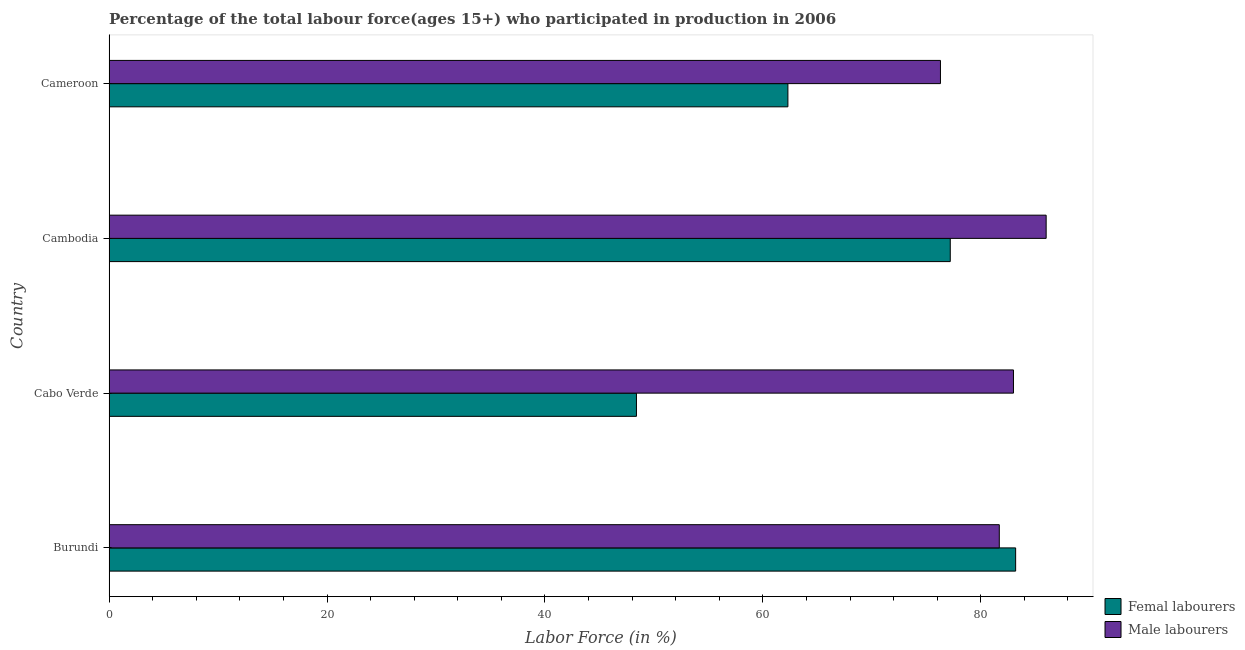How many different coloured bars are there?
Keep it short and to the point. 2. How many groups of bars are there?
Give a very brief answer. 4. Are the number of bars on each tick of the Y-axis equal?
Your answer should be compact. Yes. How many bars are there on the 2nd tick from the top?
Offer a terse response. 2. How many bars are there on the 2nd tick from the bottom?
Ensure brevity in your answer.  2. What is the label of the 2nd group of bars from the top?
Give a very brief answer. Cambodia. In how many cases, is the number of bars for a given country not equal to the number of legend labels?
Ensure brevity in your answer.  0. What is the percentage of female labor force in Cambodia?
Provide a succinct answer. 77.2. Across all countries, what is the minimum percentage of female labor force?
Your response must be concise. 48.4. In which country was the percentage of female labor force maximum?
Give a very brief answer. Burundi. In which country was the percentage of female labor force minimum?
Provide a succinct answer. Cabo Verde. What is the total percentage of female labor force in the graph?
Offer a terse response. 271.1. What is the difference between the percentage of female labor force in Burundi and that in Cameroon?
Your answer should be compact. 20.9. What is the difference between the percentage of female labor force in Burundi and the percentage of male labour force in Cameroon?
Make the answer very short. 6.9. What is the average percentage of male labour force per country?
Make the answer very short. 81.75. In how many countries, is the percentage of male labour force greater than 8 %?
Keep it short and to the point. 4. Is the difference between the percentage of male labour force in Burundi and Cameroon greater than the difference between the percentage of female labor force in Burundi and Cameroon?
Ensure brevity in your answer.  No. What does the 1st bar from the top in Cabo Verde represents?
Offer a terse response. Male labourers. What does the 1st bar from the bottom in Cabo Verde represents?
Offer a terse response. Femal labourers. Are all the bars in the graph horizontal?
Give a very brief answer. Yes. What is the difference between two consecutive major ticks on the X-axis?
Your response must be concise. 20. Does the graph contain any zero values?
Keep it short and to the point. No. Where does the legend appear in the graph?
Give a very brief answer. Bottom right. What is the title of the graph?
Provide a succinct answer. Percentage of the total labour force(ages 15+) who participated in production in 2006. Does "Subsidies" appear as one of the legend labels in the graph?
Provide a succinct answer. No. What is the Labor Force (in %) in Femal labourers in Burundi?
Your response must be concise. 83.2. What is the Labor Force (in %) in Male labourers in Burundi?
Give a very brief answer. 81.7. What is the Labor Force (in %) of Femal labourers in Cabo Verde?
Keep it short and to the point. 48.4. What is the Labor Force (in %) in Male labourers in Cabo Verde?
Your answer should be compact. 83. What is the Labor Force (in %) in Femal labourers in Cambodia?
Your response must be concise. 77.2. What is the Labor Force (in %) in Femal labourers in Cameroon?
Make the answer very short. 62.3. What is the Labor Force (in %) of Male labourers in Cameroon?
Provide a succinct answer. 76.3. Across all countries, what is the maximum Labor Force (in %) in Femal labourers?
Your answer should be compact. 83.2. Across all countries, what is the maximum Labor Force (in %) of Male labourers?
Your response must be concise. 86. Across all countries, what is the minimum Labor Force (in %) in Femal labourers?
Keep it short and to the point. 48.4. Across all countries, what is the minimum Labor Force (in %) of Male labourers?
Your response must be concise. 76.3. What is the total Labor Force (in %) in Femal labourers in the graph?
Offer a terse response. 271.1. What is the total Labor Force (in %) in Male labourers in the graph?
Keep it short and to the point. 327. What is the difference between the Labor Force (in %) of Femal labourers in Burundi and that in Cabo Verde?
Offer a very short reply. 34.8. What is the difference between the Labor Force (in %) in Male labourers in Burundi and that in Cabo Verde?
Give a very brief answer. -1.3. What is the difference between the Labor Force (in %) of Femal labourers in Burundi and that in Cameroon?
Give a very brief answer. 20.9. What is the difference between the Labor Force (in %) of Male labourers in Burundi and that in Cameroon?
Offer a very short reply. 5.4. What is the difference between the Labor Force (in %) of Femal labourers in Cabo Verde and that in Cambodia?
Ensure brevity in your answer.  -28.8. What is the difference between the Labor Force (in %) in Femal labourers in Cambodia and that in Cameroon?
Offer a very short reply. 14.9. What is the difference between the Labor Force (in %) of Femal labourers in Burundi and the Labor Force (in %) of Male labourers in Cameroon?
Offer a very short reply. 6.9. What is the difference between the Labor Force (in %) of Femal labourers in Cabo Verde and the Labor Force (in %) of Male labourers in Cambodia?
Keep it short and to the point. -37.6. What is the difference between the Labor Force (in %) of Femal labourers in Cabo Verde and the Labor Force (in %) of Male labourers in Cameroon?
Your answer should be very brief. -27.9. What is the difference between the Labor Force (in %) in Femal labourers in Cambodia and the Labor Force (in %) in Male labourers in Cameroon?
Your answer should be compact. 0.9. What is the average Labor Force (in %) in Femal labourers per country?
Keep it short and to the point. 67.78. What is the average Labor Force (in %) of Male labourers per country?
Ensure brevity in your answer.  81.75. What is the difference between the Labor Force (in %) of Femal labourers and Labor Force (in %) of Male labourers in Cabo Verde?
Ensure brevity in your answer.  -34.6. What is the ratio of the Labor Force (in %) of Femal labourers in Burundi to that in Cabo Verde?
Provide a succinct answer. 1.72. What is the ratio of the Labor Force (in %) in Male labourers in Burundi to that in Cabo Verde?
Offer a terse response. 0.98. What is the ratio of the Labor Force (in %) of Femal labourers in Burundi to that in Cambodia?
Give a very brief answer. 1.08. What is the ratio of the Labor Force (in %) in Femal labourers in Burundi to that in Cameroon?
Provide a short and direct response. 1.34. What is the ratio of the Labor Force (in %) of Male labourers in Burundi to that in Cameroon?
Give a very brief answer. 1.07. What is the ratio of the Labor Force (in %) in Femal labourers in Cabo Verde to that in Cambodia?
Your answer should be compact. 0.63. What is the ratio of the Labor Force (in %) of Male labourers in Cabo Verde to that in Cambodia?
Ensure brevity in your answer.  0.97. What is the ratio of the Labor Force (in %) in Femal labourers in Cabo Verde to that in Cameroon?
Make the answer very short. 0.78. What is the ratio of the Labor Force (in %) in Male labourers in Cabo Verde to that in Cameroon?
Your answer should be compact. 1.09. What is the ratio of the Labor Force (in %) in Femal labourers in Cambodia to that in Cameroon?
Your answer should be compact. 1.24. What is the ratio of the Labor Force (in %) in Male labourers in Cambodia to that in Cameroon?
Your answer should be compact. 1.13. What is the difference between the highest and the second highest Labor Force (in %) of Male labourers?
Ensure brevity in your answer.  3. What is the difference between the highest and the lowest Labor Force (in %) of Femal labourers?
Your answer should be compact. 34.8. What is the difference between the highest and the lowest Labor Force (in %) in Male labourers?
Your answer should be compact. 9.7. 